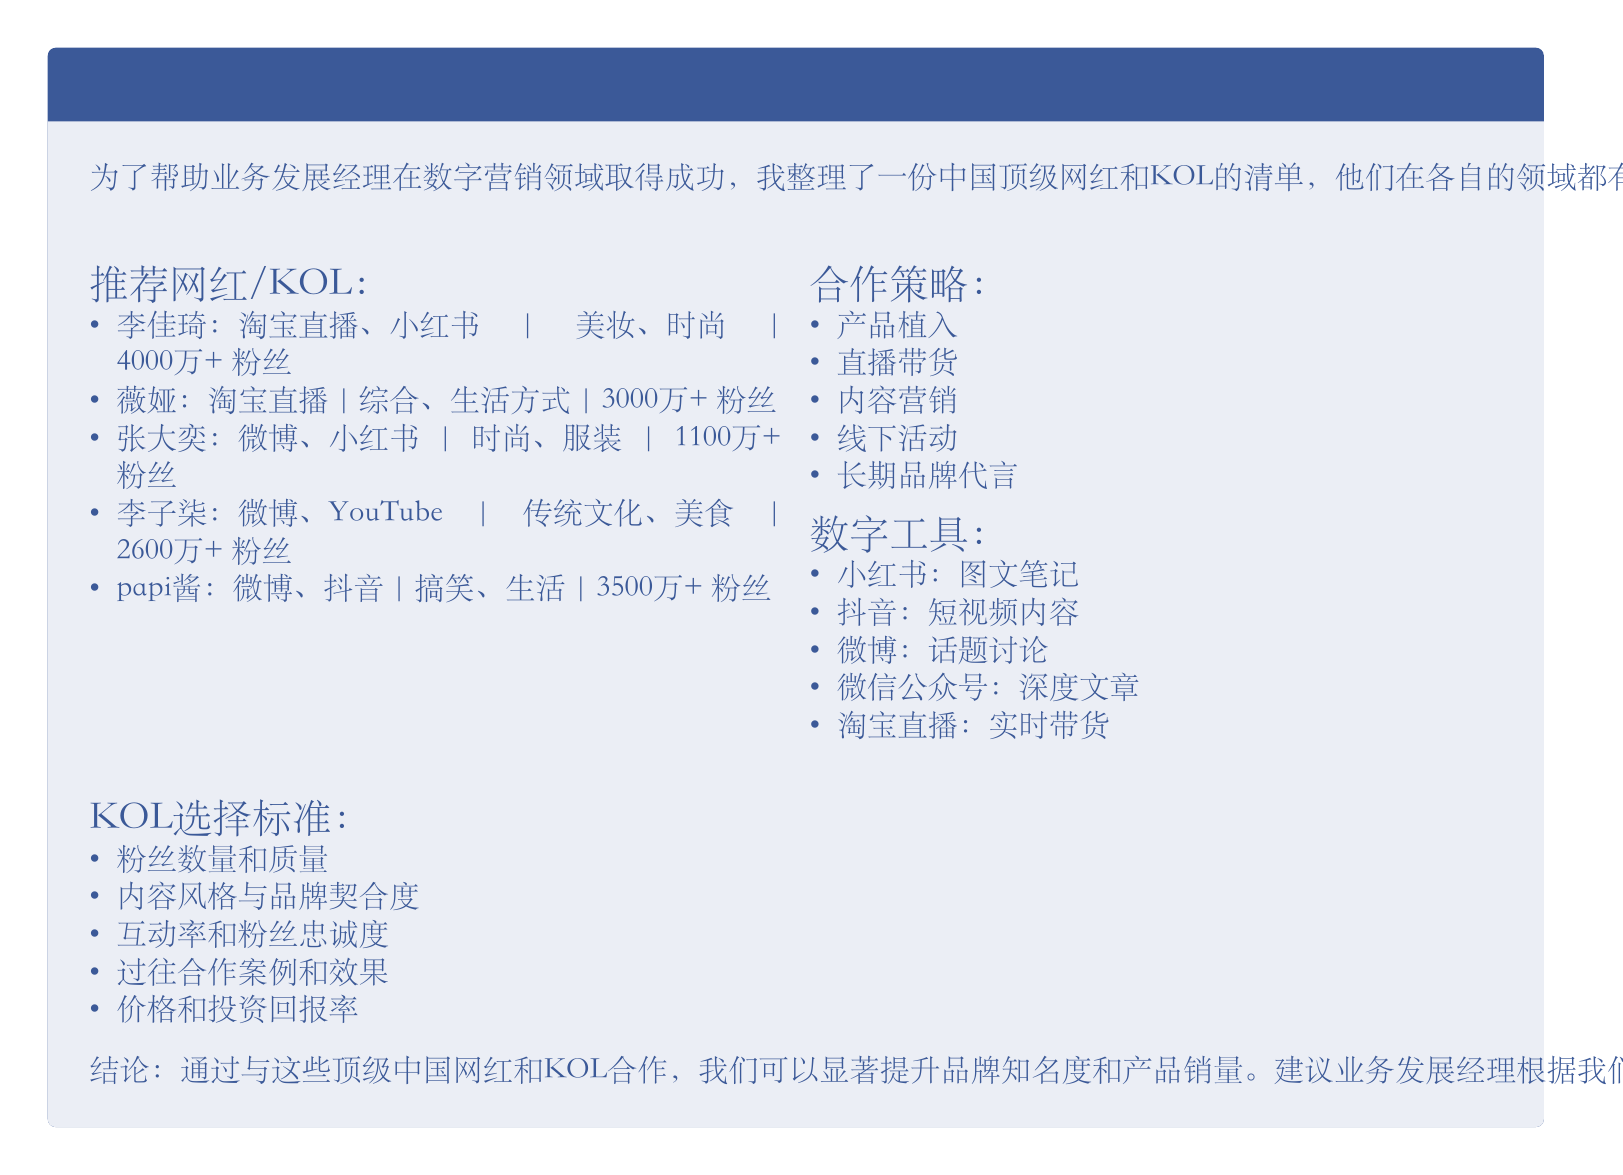推荐中国网红和关键意见领袖（KOL）合作机会的目的是什么？ 为了帮助业务发展经理在数字营销领域取得成功
Answer: 帮助业务发展经理 李佳琦活跃在哪些平台？ 李佳琦在淘宝直播和小红书上活跃
Answer: 淘宝直播、小红书 薇娅的粉丝数量是多少？ 薇娅的粉丝数量在文档中指出为3000万+
Answer: 3000万+ 产品植入的定义是什么？ 产品植入是指在KOL的内容中自然融入产品展示
Answer: 在KOL的内容中自然融入产品展示 选择KOL时需要考虑哪些标准？ 选择KOL需要考虑粉丝数量和质量等多个标准
Answer: 粉丝数量和质量 能否描述papi酱的内容风格？ p53中提到papi酱的幽默风格独特
Answer: 幽默风格独特 推荐的数字工具中，哪个用于发布深度文章？ 文档中提到微信公众号用于发布深度文章
Answer: 微信公众号 选择 KOL 时，互动率的重要性是什么？ 互动率和粉丝忠诚度是重要的选择标准之一
Answer: 重要的选择标准 建议品牌合作的方式中，哪一种涉及实时直播？ 直播带货表示与网红合作进行实时直播的销售
Answer: 直播带货 通过与这些顶级中国网红和KOL合作的最终目标是什么？ 提升品牌知名度和产品销量是最终目标
Answer: 提升品牌知名度和产品销量 